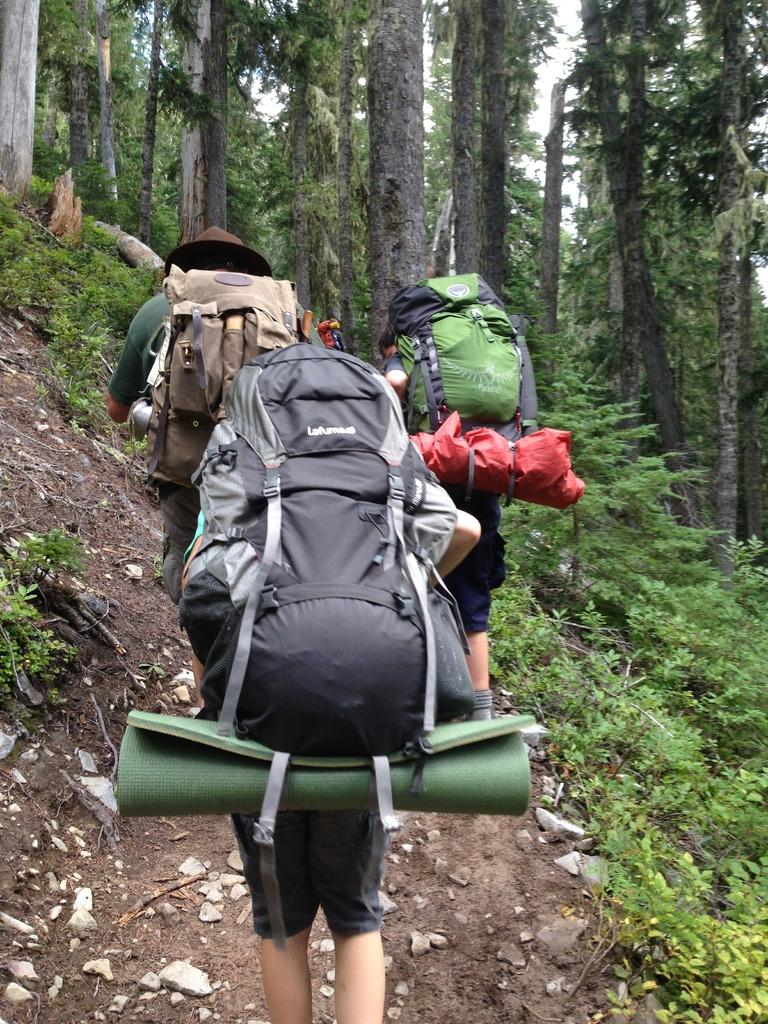How many people are in the image? There are three persons in the image. What are the persons doing in the image? The persons are trekking. What can be seen in the background of the image? There are trees in the background of the image. Who is the creator of the weather in the image? There is no mention of weather in the image, and therefore no creator can be identified. 